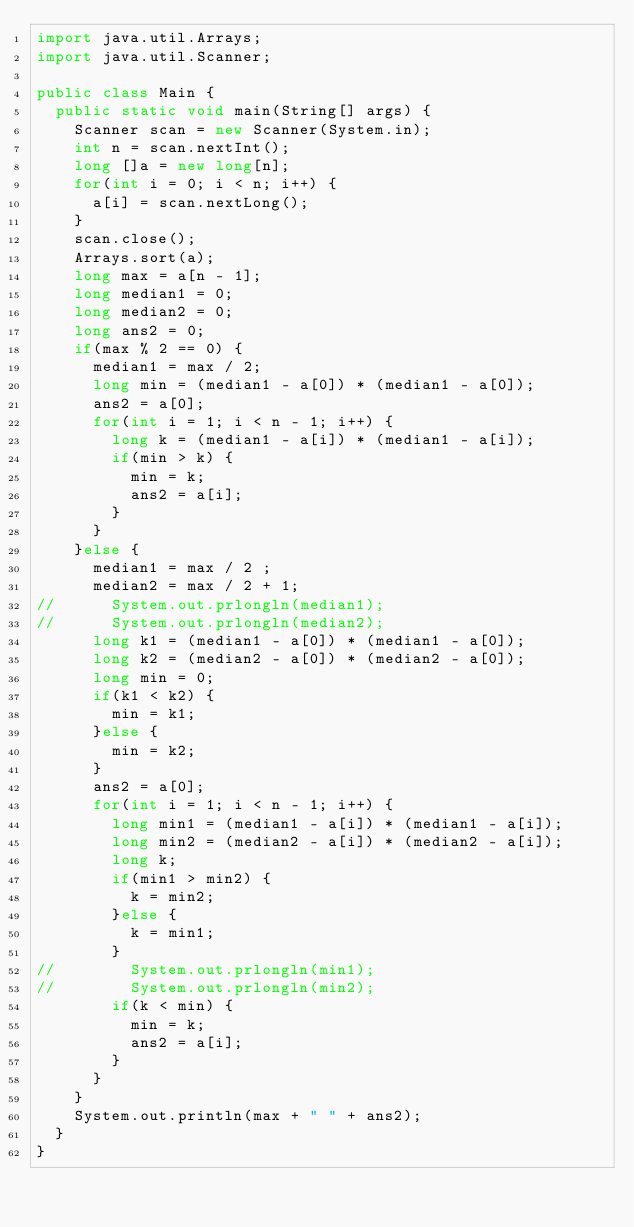<code> <loc_0><loc_0><loc_500><loc_500><_Java_>import java.util.Arrays;
import java.util.Scanner;

public class Main {
	public static void main(String[] args) {
		Scanner scan = new Scanner(System.in);
		int n = scan.nextInt();
		long []a = new long[n];
		for(int i = 0; i < n; i++) {
			a[i] = scan.nextLong();
		}
		scan.close();
		Arrays.sort(a);
		long max = a[n - 1];
		long median1 = 0;
		long median2 = 0;
		long ans2 = 0;
		if(max % 2 == 0) {
			median1 = max / 2;
			long min = (median1 - a[0]) * (median1 - a[0]);
			ans2 = a[0];
			for(int i = 1; i < n - 1; i++) {
				long k = (median1 - a[i]) * (median1 - a[i]);
				if(min > k) {
					min = k;
					ans2 = a[i];
				}
			}
		}else {
			median1 = max / 2 ;
			median2 = max / 2 + 1;
//			System.out.prlongln(median1);
//			System.out.prlongln(median2);
			long k1 = (median1 - a[0]) * (median1 - a[0]);
			long k2 = (median2 - a[0]) * (median2 - a[0]);
			long min = 0;
			if(k1 < k2) {
				min = k1;
			}else {
				min = k2;
			}
			ans2 = a[0];
			for(int i = 1; i < n - 1; i++) {
				long min1 = (median1 - a[i]) * (median1 - a[i]);
				long min2 = (median2 - a[i]) * (median2 - a[i]);
				long k;
				if(min1 > min2) {
					k = min2;
				}else {
					k = min1;
				}
//				System.out.prlongln(min1);
//				System.out.prlongln(min2);
				if(k < min) {
					min = k;
					ans2 = a[i];
				}
			}
		}
		System.out.println(max + " " + ans2);
	}
}</code> 